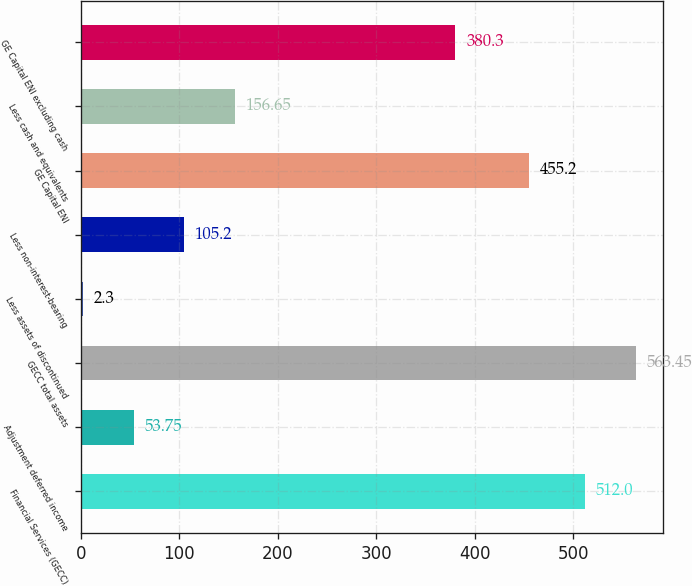Convert chart to OTSL. <chart><loc_0><loc_0><loc_500><loc_500><bar_chart><fcel>Financial Services (GECC)<fcel>Adjustment deferred income<fcel>GECC total assets<fcel>Less assets of discontinued<fcel>Less non-interest-bearing<fcel>GE Capital ENI<fcel>Less cash and equivalents<fcel>GE Capital ENI excluding cash<nl><fcel>512<fcel>53.75<fcel>563.45<fcel>2.3<fcel>105.2<fcel>455.2<fcel>156.65<fcel>380.3<nl></chart> 